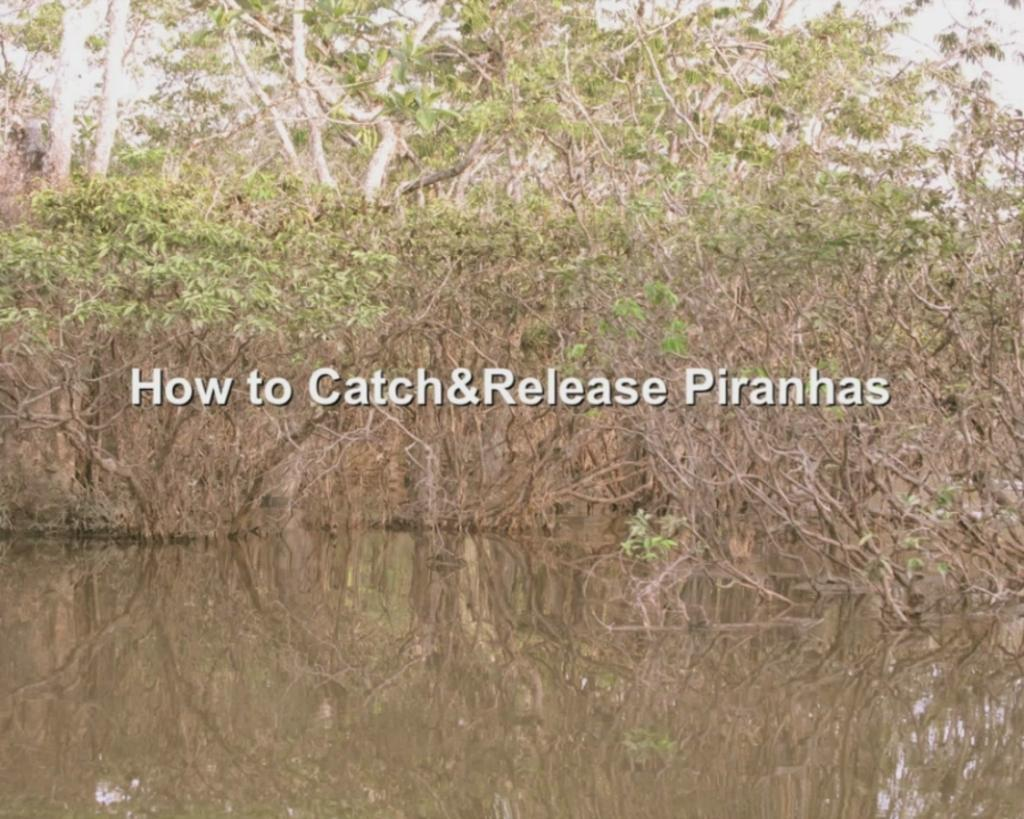What is located at the front of the image? There is water in the front of the image. What can be seen in the background of the image? There are trees in the background of the image. What is visible through the trees? The sky is visible through the trees. What is in the middle of the image? There is text or an image in the middle of the image. How many cars can be seen driving through the memory in the image? There are no cars or memories present in the image; it features water, trees, and an image or text in the middle. 